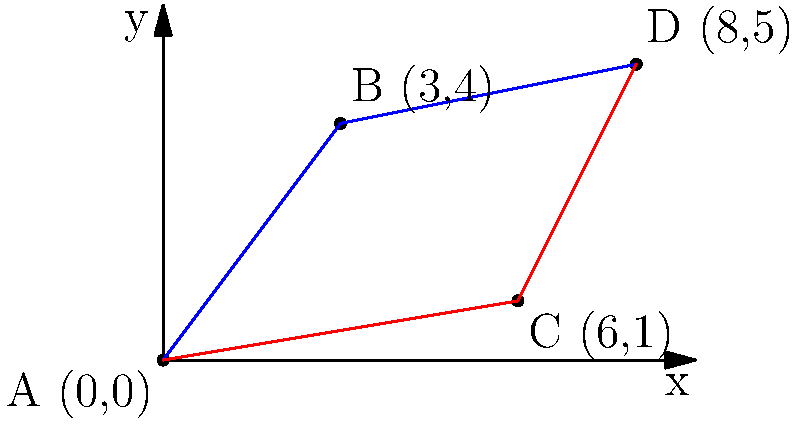A new public transportation route is being planned to connect points A, B, C, and D. The city wants to choose the most cost-effective route. The cost of travel is directly proportional to the distance. Which route is more cost-effective: A-B-D or A-C-D? Calculate the difference in distance between the two routes. To solve this problem, we need to calculate the total distance for each route and compare them. We'll use the distance formula: $d = \sqrt{(x_2-x_1)^2 + (y_2-y_1)^2}$

Route A-B-D:
1. Distance AB: $d_{AB} = \sqrt{(3-0)^2 + (4-0)^2} = \sqrt{9 + 16} = \sqrt{25} = 5$
2. Distance BD: $d_{BD} = \sqrt{(8-3)^2 + (5-4)^2} = \sqrt{25 + 1} = \sqrt{26} = 5.1$
3. Total distance A-B-D: $5 + 5.1 = 10.1$

Route A-C-D:
1. Distance AC: $d_{AC} = \sqrt{(6-0)^2 + (1-0)^2} = \sqrt{36 + 1} = \sqrt{37} = 6.08$
2. Distance CD: $d_{CD} = \sqrt{(8-6)^2 + (5-1)^2} = \sqrt{4 + 16} = \sqrt{20} = 4.47$
3. Total distance A-C-D: $6.08 + 4.47 = 10.55$

The difference in distance:
$10.55 - 10.1 = 0.45$

Therefore, route A-B-D is more cost-effective as it is shorter by 0.45 units.
Answer: A-B-D; 0.45 units shorter 